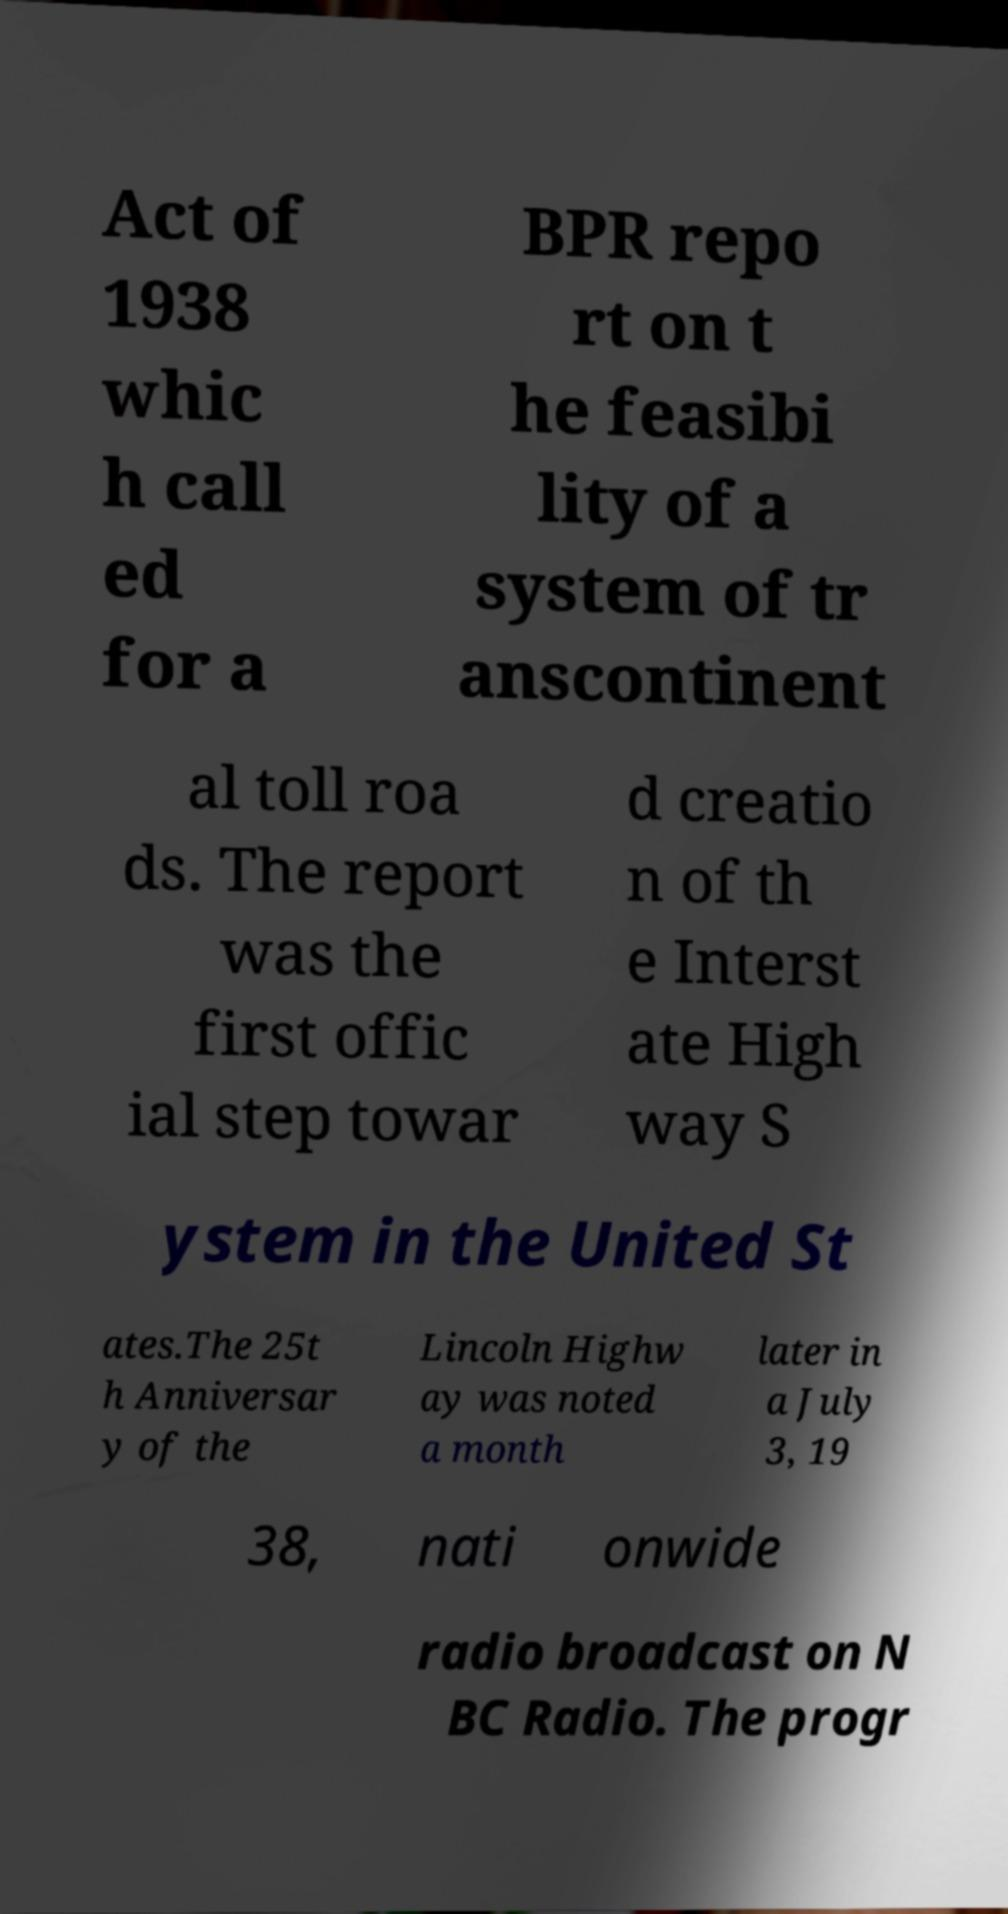Could you assist in decoding the text presented in this image and type it out clearly? Act of 1938 whic h call ed for a BPR repo rt on t he feasibi lity of a system of tr anscontinent al toll roa ds. The report was the first offic ial step towar d creatio n of th e Interst ate High way S ystem in the United St ates.The 25t h Anniversar y of the Lincoln Highw ay was noted a month later in a July 3, 19 38, nati onwide radio broadcast on N BC Radio. The progr 